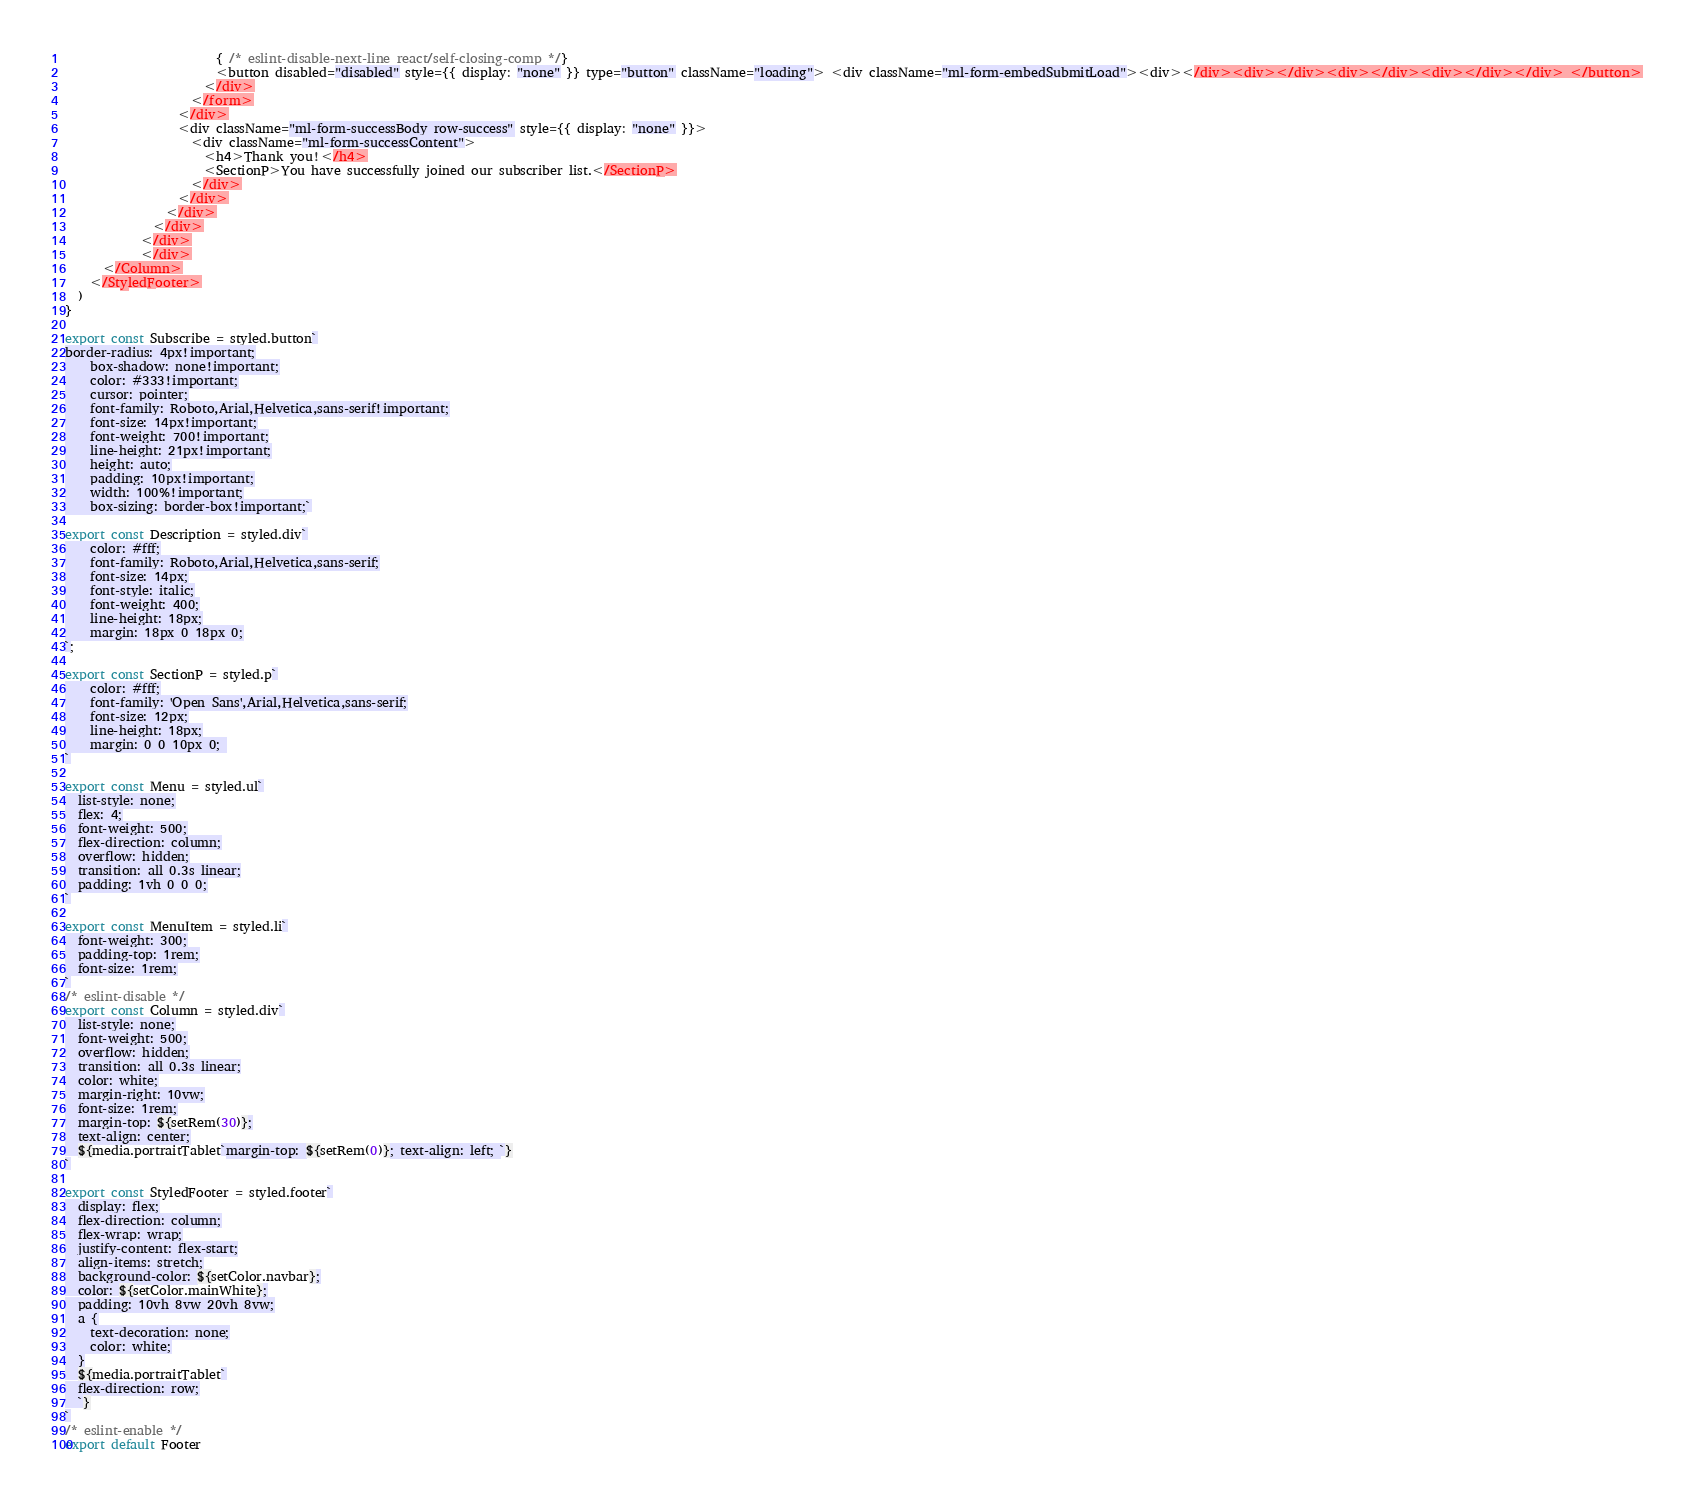<code> <loc_0><loc_0><loc_500><loc_500><_JavaScript_>                        { /* eslint-disable-next-line react/self-closing-comp */}
                        <button disabled="disabled" style={{ display: "none" }} type="button" className="loading"> <div className="ml-form-embedSubmitLoad"><div></div><div></div><div></div><div></div></div> </button>
                      </div>
                    </form>
                  </div>
                  <div className="ml-form-successBody row-success" style={{ display: "none" }}>
                    <div className="ml-form-successContent">
                      <h4>Thank you!</h4>
                      <SectionP>You have successfully joined our subscriber list.</SectionP>
                    </div>
                  </div>
                </div>
              </div>
            </div>
            </div>
      </Column>
    </StyledFooter>
  )
}

export const Subscribe = styled.button`
border-radius: 4px!important;
    box-shadow: none!important;
    color: #333!important;
    cursor: pointer;
    font-family: Roboto,Arial,Helvetica,sans-serif!important;
    font-size: 14px!important;
    font-weight: 700!important;
    line-height: 21px!important;
    height: auto;
    padding: 10px!important;
    width: 100%!important;
    box-sizing: border-box!important;`

export const Description = styled.div`
    color: #fff;
    font-family: Roboto,Arial,Helvetica,sans-serif;
    font-size: 14px;
    font-style: italic;
    font-weight: 400;
    line-height: 18px;
    margin: 18px 0 18px 0;
`;

export const SectionP = styled.p`
    color: #fff;
    font-family: 'Open Sans',Arial,Helvetica,sans-serif;
    font-size: 12px;
    line-height: 18px;
    margin: 0 0 10px 0; 
`

export const Menu = styled.ul`
  list-style: none;
  flex: 4;
  font-weight: 500;
  flex-direction: column;
  overflow: hidden;
  transition: all 0.3s linear;
  padding: 1vh 0 0 0;
`

export const MenuItem = styled.li`
  font-weight: 300;
  padding-top: 1rem;
  font-size: 1rem;
`
/* eslint-disable */
export const Column = styled.div`
  list-style: none;
  font-weight: 500;
  overflow: hidden;
  transition: all 0.3s linear;
  color: white;
  margin-right: 10vw;
  font-size: 1rem;
  margin-top: ${setRem(30)};
  text-align: center;
  ${media.portraitTablet`margin-top: ${setRem(0)}; text-align: left; `}
`

export const StyledFooter = styled.footer`
  display: flex;
  flex-direction: column;
  flex-wrap: wrap;
  justify-content: flex-start;
  align-items: stretch;
  background-color: ${setColor.navbar};
  color: ${setColor.mainWhite};
  padding: 10vh 8vw 20vh 8vw;
  a {
    text-decoration: none;
    color: white;
  }
  ${media.portraitTablet`
  flex-direction: row;
  `}
`
/* eslint-enable */
export default Footer
</code> 